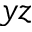Convert formula to latex. <formula><loc_0><loc_0><loc_500><loc_500>y z</formula> 